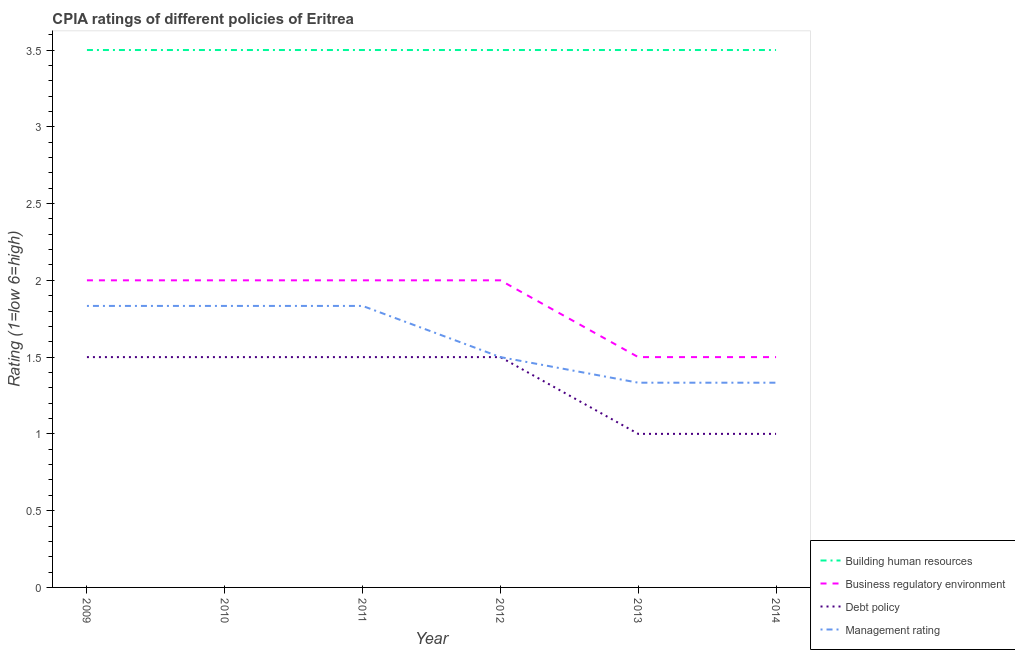How many different coloured lines are there?
Your response must be concise. 4. Across all years, what is the maximum cpia rating of management?
Make the answer very short. 1.83. Across all years, what is the minimum cpia rating of management?
Offer a very short reply. 1.33. In which year was the cpia rating of debt policy maximum?
Provide a short and direct response. 2009. In which year was the cpia rating of management minimum?
Ensure brevity in your answer.  2014. What is the difference between the cpia rating of building human resources in 2011 and that in 2014?
Your answer should be compact. 0. What is the difference between the cpia rating of debt policy in 2011 and the cpia rating of management in 2009?
Offer a very short reply. -0.33. What is the average cpia rating of management per year?
Offer a terse response. 1.61. In the year 2010, what is the difference between the cpia rating of management and cpia rating of business regulatory environment?
Provide a short and direct response. -0.17. What is the ratio of the cpia rating of business regulatory environment in 2009 to that in 2010?
Ensure brevity in your answer.  1. Is the difference between the cpia rating of business regulatory environment in 2010 and 2014 greater than the difference between the cpia rating of building human resources in 2010 and 2014?
Make the answer very short. Yes. What is the difference between the highest and the second highest cpia rating of debt policy?
Make the answer very short. 0. What is the difference between the highest and the lowest cpia rating of debt policy?
Your answer should be very brief. 0.5. Is the cpia rating of debt policy strictly greater than the cpia rating of management over the years?
Your answer should be compact. No. Is the cpia rating of debt policy strictly less than the cpia rating of building human resources over the years?
Your response must be concise. Yes. How many years are there in the graph?
Offer a very short reply. 6. What is the difference between two consecutive major ticks on the Y-axis?
Give a very brief answer. 0.5. Are the values on the major ticks of Y-axis written in scientific E-notation?
Give a very brief answer. No. Does the graph contain any zero values?
Keep it short and to the point. No. Does the graph contain grids?
Your response must be concise. No. Where does the legend appear in the graph?
Your response must be concise. Bottom right. How are the legend labels stacked?
Your answer should be compact. Vertical. What is the title of the graph?
Make the answer very short. CPIA ratings of different policies of Eritrea. Does "Burnt food" appear as one of the legend labels in the graph?
Offer a terse response. No. What is the Rating (1=low 6=high) in Building human resources in 2009?
Ensure brevity in your answer.  3.5. What is the Rating (1=low 6=high) of Management rating in 2009?
Make the answer very short. 1.83. What is the Rating (1=low 6=high) in Debt policy in 2010?
Your answer should be compact. 1.5. What is the Rating (1=low 6=high) in Management rating in 2010?
Keep it short and to the point. 1.83. What is the Rating (1=low 6=high) in Management rating in 2011?
Provide a short and direct response. 1.83. What is the Rating (1=low 6=high) in Building human resources in 2012?
Offer a very short reply. 3.5. What is the Rating (1=low 6=high) of Business regulatory environment in 2012?
Offer a terse response. 2. What is the Rating (1=low 6=high) of Management rating in 2012?
Provide a succinct answer. 1.5. What is the Rating (1=low 6=high) in Building human resources in 2013?
Your response must be concise. 3.5. What is the Rating (1=low 6=high) of Business regulatory environment in 2013?
Ensure brevity in your answer.  1.5. What is the Rating (1=low 6=high) of Management rating in 2013?
Make the answer very short. 1.33. What is the Rating (1=low 6=high) of Building human resources in 2014?
Provide a short and direct response. 3.5. What is the Rating (1=low 6=high) in Debt policy in 2014?
Provide a succinct answer. 1. What is the Rating (1=low 6=high) in Management rating in 2014?
Provide a succinct answer. 1.33. Across all years, what is the maximum Rating (1=low 6=high) of Management rating?
Keep it short and to the point. 1.83. Across all years, what is the minimum Rating (1=low 6=high) of Building human resources?
Your response must be concise. 3.5. Across all years, what is the minimum Rating (1=low 6=high) of Debt policy?
Your answer should be very brief. 1. Across all years, what is the minimum Rating (1=low 6=high) in Management rating?
Your response must be concise. 1.33. What is the total Rating (1=low 6=high) in Management rating in the graph?
Ensure brevity in your answer.  9.67. What is the difference between the Rating (1=low 6=high) in Business regulatory environment in 2009 and that in 2010?
Provide a short and direct response. 0. What is the difference between the Rating (1=low 6=high) in Debt policy in 2009 and that in 2010?
Give a very brief answer. 0. What is the difference between the Rating (1=low 6=high) of Management rating in 2009 and that in 2010?
Offer a terse response. 0. What is the difference between the Rating (1=low 6=high) of Building human resources in 2009 and that in 2011?
Your answer should be compact. 0. What is the difference between the Rating (1=low 6=high) in Debt policy in 2009 and that in 2011?
Offer a terse response. 0. What is the difference between the Rating (1=low 6=high) in Management rating in 2009 and that in 2011?
Provide a short and direct response. 0. What is the difference between the Rating (1=low 6=high) of Building human resources in 2009 and that in 2012?
Make the answer very short. 0. What is the difference between the Rating (1=low 6=high) of Debt policy in 2009 and that in 2012?
Make the answer very short. 0. What is the difference between the Rating (1=low 6=high) in Management rating in 2009 and that in 2012?
Provide a succinct answer. 0.33. What is the difference between the Rating (1=low 6=high) of Business regulatory environment in 2009 and that in 2013?
Keep it short and to the point. 0.5. What is the difference between the Rating (1=low 6=high) in Debt policy in 2009 and that in 2013?
Make the answer very short. 0.5. What is the difference between the Rating (1=low 6=high) in Business regulatory environment in 2009 and that in 2014?
Keep it short and to the point. 0.5. What is the difference between the Rating (1=low 6=high) of Debt policy in 2009 and that in 2014?
Offer a very short reply. 0.5. What is the difference between the Rating (1=low 6=high) in Management rating in 2009 and that in 2014?
Offer a very short reply. 0.5. What is the difference between the Rating (1=low 6=high) of Building human resources in 2010 and that in 2011?
Give a very brief answer. 0. What is the difference between the Rating (1=low 6=high) of Debt policy in 2010 and that in 2011?
Make the answer very short. 0. What is the difference between the Rating (1=low 6=high) of Business regulatory environment in 2010 and that in 2012?
Offer a terse response. 0. What is the difference between the Rating (1=low 6=high) in Debt policy in 2010 and that in 2012?
Your answer should be very brief. 0. What is the difference between the Rating (1=low 6=high) in Building human resources in 2010 and that in 2013?
Offer a very short reply. 0. What is the difference between the Rating (1=low 6=high) in Business regulatory environment in 2010 and that in 2014?
Your answer should be very brief. 0.5. What is the difference between the Rating (1=low 6=high) in Debt policy in 2010 and that in 2014?
Keep it short and to the point. 0.5. What is the difference between the Rating (1=low 6=high) of Management rating in 2010 and that in 2014?
Make the answer very short. 0.5. What is the difference between the Rating (1=low 6=high) of Management rating in 2011 and that in 2012?
Your answer should be very brief. 0.33. What is the difference between the Rating (1=low 6=high) in Building human resources in 2011 and that in 2013?
Provide a succinct answer. 0. What is the difference between the Rating (1=low 6=high) in Debt policy in 2011 and that in 2013?
Offer a terse response. 0.5. What is the difference between the Rating (1=low 6=high) of Management rating in 2011 and that in 2013?
Make the answer very short. 0.5. What is the difference between the Rating (1=low 6=high) in Building human resources in 2011 and that in 2014?
Offer a terse response. 0. What is the difference between the Rating (1=low 6=high) in Business regulatory environment in 2011 and that in 2014?
Your answer should be very brief. 0.5. What is the difference between the Rating (1=low 6=high) of Debt policy in 2011 and that in 2014?
Provide a short and direct response. 0.5. What is the difference between the Rating (1=low 6=high) of Business regulatory environment in 2012 and that in 2013?
Provide a short and direct response. 0.5. What is the difference between the Rating (1=low 6=high) of Debt policy in 2012 and that in 2013?
Make the answer very short. 0.5. What is the difference between the Rating (1=low 6=high) in Management rating in 2012 and that in 2013?
Keep it short and to the point. 0.17. What is the difference between the Rating (1=low 6=high) of Building human resources in 2012 and that in 2014?
Provide a short and direct response. 0. What is the difference between the Rating (1=low 6=high) in Business regulatory environment in 2013 and that in 2014?
Your answer should be compact. 0. What is the difference between the Rating (1=low 6=high) in Management rating in 2013 and that in 2014?
Provide a succinct answer. 0. What is the difference between the Rating (1=low 6=high) of Building human resources in 2009 and the Rating (1=low 6=high) of Business regulatory environment in 2010?
Make the answer very short. 1.5. What is the difference between the Rating (1=low 6=high) in Building human resources in 2009 and the Rating (1=low 6=high) in Management rating in 2010?
Provide a succinct answer. 1.67. What is the difference between the Rating (1=low 6=high) of Business regulatory environment in 2009 and the Rating (1=low 6=high) of Management rating in 2010?
Your response must be concise. 0.17. What is the difference between the Rating (1=low 6=high) in Debt policy in 2009 and the Rating (1=low 6=high) in Management rating in 2010?
Your response must be concise. -0.33. What is the difference between the Rating (1=low 6=high) in Building human resources in 2009 and the Rating (1=low 6=high) in Business regulatory environment in 2011?
Make the answer very short. 1.5. What is the difference between the Rating (1=low 6=high) in Building human resources in 2009 and the Rating (1=low 6=high) in Debt policy in 2011?
Keep it short and to the point. 2. What is the difference between the Rating (1=low 6=high) of Building human resources in 2009 and the Rating (1=low 6=high) of Management rating in 2011?
Offer a terse response. 1.67. What is the difference between the Rating (1=low 6=high) in Business regulatory environment in 2009 and the Rating (1=low 6=high) in Debt policy in 2011?
Give a very brief answer. 0.5. What is the difference between the Rating (1=low 6=high) in Business regulatory environment in 2009 and the Rating (1=low 6=high) in Management rating in 2011?
Provide a succinct answer. 0.17. What is the difference between the Rating (1=low 6=high) of Building human resources in 2009 and the Rating (1=low 6=high) of Debt policy in 2012?
Keep it short and to the point. 2. What is the difference between the Rating (1=low 6=high) of Building human resources in 2009 and the Rating (1=low 6=high) of Business regulatory environment in 2013?
Make the answer very short. 2. What is the difference between the Rating (1=low 6=high) of Building human resources in 2009 and the Rating (1=low 6=high) of Debt policy in 2013?
Provide a succinct answer. 2.5. What is the difference between the Rating (1=low 6=high) in Building human resources in 2009 and the Rating (1=low 6=high) in Management rating in 2013?
Give a very brief answer. 2.17. What is the difference between the Rating (1=low 6=high) in Business regulatory environment in 2009 and the Rating (1=low 6=high) in Management rating in 2013?
Your answer should be very brief. 0.67. What is the difference between the Rating (1=low 6=high) of Debt policy in 2009 and the Rating (1=low 6=high) of Management rating in 2013?
Keep it short and to the point. 0.17. What is the difference between the Rating (1=low 6=high) in Building human resources in 2009 and the Rating (1=low 6=high) in Management rating in 2014?
Offer a very short reply. 2.17. What is the difference between the Rating (1=low 6=high) of Business regulatory environment in 2009 and the Rating (1=low 6=high) of Management rating in 2014?
Offer a terse response. 0.67. What is the difference between the Rating (1=low 6=high) in Debt policy in 2009 and the Rating (1=low 6=high) in Management rating in 2014?
Your response must be concise. 0.17. What is the difference between the Rating (1=low 6=high) of Business regulatory environment in 2010 and the Rating (1=low 6=high) of Debt policy in 2011?
Offer a terse response. 0.5. What is the difference between the Rating (1=low 6=high) in Building human resources in 2010 and the Rating (1=low 6=high) in Debt policy in 2012?
Your response must be concise. 2. What is the difference between the Rating (1=low 6=high) in Business regulatory environment in 2010 and the Rating (1=low 6=high) in Debt policy in 2012?
Your response must be concise. 0.5. What is the difference between the Rating (1=low 6=high) in Debt policy in 2010 and the Rating (1=low 6=high) in Management rating in 2012?
Give a very brief answer. 0. What is the difference between the Rating (1=low 6=high) of Building human resources in 2010 and the Rating (1=low 6=high) of Management rating in 2013?
Your response must be concise. 2.17. What is the difference between the Rating (1=low 6=high) of Building human resources in 2010 and the Rating (1=low 6=high) of Debt policy in 2014?
Keep it short and to the point. 2.5. What is the difference between the Rating (1=low 6=high) in Building human resources in 2010 and the Rating (1=low 6=high) in Management rating in 2014?
Make the answer very short. 2.17. What is the difference between the Rating (1=low 6=high) of Business regulatory environment in 2010 and the Rating (1=low 6=high) of Debt policy in 2014?
Offer a very short reply. 1. What is the difference between the Rating (1=low 6=high) in Debt policy in 2010 and the Rating (1=low 6=high) in Management rating in 2014?
Make the answer very short. 0.17. What is the difference between the Rating (1=low 6=high) in Building human resources in 2011 and the Rating (1=low 6=high) in Business regulatory environment in 2012?
Offer a terse response. 1.5. What is the difference between the Rating (1=low 6=high) in Building human resources in 2011 and the Rating (1=low 6=high) in Debt policy in 2012?
Your answer should be compact. 2. What is the difference between the Rating (1=low 6=high) in Business regulatory environment in 2011 and the Rating (1=low 6=high) in Debt policy in 2012?
Your answer should be very brief. 0.5. What is the difference between the Rating (1=low 6=high) in Business regulatory environment in 2011 and the Rating (1=low 6=high) in Management rating in 2012?
Provide a short and direct response. 0.5. What is the difference between the Rating (1=low 6=high) in Building human resources in 2011 and the Rating (1=low 6=high) in Debt policy in 2013?
Provide a short and direct response. 2.5. What is the difference between the Rating (1=low 6=high) of Building human resources in 2011 and the Rating (1=low 6=high) of Management rating in 2013?
Your answer should be very brief. 2.17. What is the difference between the Rating (1=low 6=high) of Business regulatory environment in 2011 and the Rating (1=low 6=high) of Debt policy in 2013?
Offer a very short reply. 1. What is the difference between the Rating (1=low 6=high) of Building human resources in 2011 and the Rating (1=low 6=high) of Debt policy in 2014?
Ensure brevity in your answer.  2.5. What is the difference between the Rating (1=low 6=high) of Building human resources in 2011 and the Rating (1=low 6=high) of Management rating in 2014?
Your answer should be compact. 2.17. What is the difference between the Rating (1=low 6=high) in Business regulatory environment in 2011 and the Rating (1=low 6=high) in Debt policy in 2014?
Give a very brief answer. 1. What is the difference between the Rating (1=low 6=high) of Business regulatory environment in 2011 and the Rating (1=low 6=high) of Management rating in 2014?
Your answer should be very brief. 0.67. What is the difference between the Rating (1=low 6=high) of Building human resources in 2012 and the Rating (1=low 6=high) of Business regulatory environment in 2013?
Ensure brevity in your answer.  2. What is the difference between the Rating (1=low 6=high) in Building human resources in 2012 and the Rating (1=low 6=high) in Debt policy in 2013?
Provide a succinct answer. 2.5. What is the difference between the Rating (1=low 6=high) in Building human resources in 2012 and the Rating (1=low 6=high) in Management rating in 2013?
Your response must be concise. 2.17. What is the difference between the Rating (1=low 6=high) in Business regulatory environment in 2012 and the Rating (1=low 6=high) in Management rating in 2013?
Provide a succinct answer. 0.67. What is the difference between the Rating (1=low 6=high) of Building human resources in 2012 and the Rating (1=low 6=high) of Business regulatory environment in 2014?
Your answer should be compact. 2. What is the difference between the Rating (1=low 6=high) in Building human resources in 2012 and the Rating (1=low 6=high) in Management rating in 2014?
Offer a terse response. 2.17. What is the difference between the Rating (1=low 6=high) in Building human resources in 2013 and the Rating (1=low 6=high) in Management rating in 2014?
Your answer should be very brief. 2.17. What is the difference between the Rating (1=low 6=high) in Debt policy in 2013 and the Rating (1=low 6=high) in Management rating in 2014?
Make the answer very short. -0.33. What is the average Rating (1=low 6=high) of Building human resources per year?
Make the answer very short. 3.5. What is the average Rating (1=low 6=high) in Business regulatory environment per year?
Ensure brevity in your answer.  1.83. What is the average Rating (1=low 6=high) of Management rating per year?
Your answer should be compact. 1.61. In the year 2009, what is the difference between the Rating (1=low 6=high) of Building human resources and Rating (1=low 6=high) of Debt policy?
Provide a short and direct response. 2. In the year 2009, what is the difference between the Rating (1=low 6=high) in Building human resources and Rating (1=low 6=high) in Management rating?
Keep it short and to the point. 1.67. In the year 2009, what is the difference between the Rating (1=low 6=high) in Business regulatory environment and Rating (1=low 6=high) in Debt policy?
Your answer should be compact. 0.5. In the year 2009, what is the difference between the Rating (1=low 6=high) of Debt policy and Rating (1=low 6=high) of Management rating?
Your answer should be very brief. -0.33. In the year 2010, what is the difference between the Rating (1=low 6=high) of Building human resources and Rating (1=low 6=high) of Debt policy?
Give a very brief answer. 2. In the year 2010, what is the difference between the Rating (1=low 6=high) of Building human resources and Rating (1=low 6=high) of Management rating?
Give a very brief answer. 1.67. In the year 2010, what is the difference between the Rating (1=low 6=high) of Business regulatory environment and Rating (1=low 6=high) of Management rating?
Your response must be concise. 0.17. In the year 2011, what is the difference between the Rating (1=low 6=high) in Building human resources and Rating (1=low 6=high) in Business regulatory environment?
Make the answer very short. 1.5. In the year 2011, what is the difference between the Rating (1=low 6=high) in Building human resources and Rating (1=low 6=high) in Management rating?
Ensure brevity in your answer.  1.67. In the year 2011, what is the difference between the Rating (1=low 6=high) of Business regulatory environment and Rating (1=low 6=high) of Debt policy?
Your answer should be compact. 0.5. In the year 2011, what is the difference between the Rating (1=low 6=high) of Debt policy and Rating (1=low 6=high) of Management rating?
Ensure brevity in your answer.  -0.33. In the year 2012, what is the difference between the Rating (1=low 6=high) of Building human resources and Rating (1=low 6=high) of Business regulatory environment?
Provide a succinct answer. 1.5. In the year 2013, what is the difference between the Rating (1=low 6=high) in Building human resources and Rating (1=low 6=high) in Debt policy?
Provide a short and direct response. 2.5. In the year 2013, what is the difference between the Rating (1=low 6=high) of Building human resources and Rating (1=low 6=high) of Management rating?
Your answer should be very brief. 2.17. In the year 2014, what is the difference between the Rating (1=low 6=high) in Building human resources and Rating (1=low 6=high) in Management rating?
Ensure brevity in your answer.  2.17. In the year 2014, what is the difference between the Rating (1=low 6=high) of Business regulatory environment and Rating (1=low 6=high) of Debt policy?
Offer a very short reply. 0.5. In the year 2014, what is the difference between the Rating (1=low 6=high) of Debt policy and Rating (1=low 6=high) of Management rating?
Your answer should be very brief. -0.33. What is the ratio of the Rating (1=low 6=high) in Building human resources in 2009 to that in 2010?
Provide a succinct answer. 1. What is the ratio of the Rating (1=low 6=high) in Business regulatory environment in 2009 to that in 2010?
Ensure brevity in your answer.  1. What is the ratio of the Rating (1=low 6=high) in Building human resources in 2009 to that in 2011?
Ensure brevity in your answer.  1. What is the ratio of the Rating (1=low 6=high) in Business regulatory environment in 2009 to that in 2011?
Ensure brevity in your answer.  1. What is the ratio of the Rating (1=low 6=high) of Debt policy in 2009 to that in 2011?
Offer a terse response. 1. What is the ratio of the Rating (1=low 6=high) of Management rating in 2009 to that in 2011?
Provide a succinct answer. 1. What is the ratio of the Rating (1=low 6=high) of Business regulatory environment in 2009 to that in 2012?
Your answer should be very brief. 1. What is the ratio of the Rating (1=low 6=high) of Debt policy in 2009 to that in 2012?
Your answer should be very brief. 1. What is the ratio of the Rating (1=low 6=high) in Management rating in 2009 to that in 2012?
Make the answer very short. 1.22. What is the ratio of the Rating (1=low 6=high) of Building human resources in 2009 to that in 2013?
Offer a very short reply. 1. What is the ratio of the Rating (1=low 6=high) of Debt policy in 2009 to that in 2013?
Keep it short and to the point. 1.5. What is the ratio of the Rating (1=low 6=high) of Management rating in 2009 to that in 2013?
Offer a very short reply. 1.38. What is the ratio of the Rating (1=low 6=high) in Business regulatory environment in 2009 to that in 2014?
Your response must be concise. 1.33. What is the ratio of the Rating (1=low 6=high) in Debt policy in 2009 to that in 2014?
Ensure brevity in your answer.  1.5. What is the ratio of the Rating (1=low 6=high) in Management rating in 2009 to that in 2014?
Provide a succinct answer. 1.38. What is the ratio of the Rating (1=low 6=high) of Debt policy in 2010 to that in 2011?
Keep it short and to the point. 1. What is the ratio of the Rating (1=low 6=high) of Management rating in 2010 to that in 2011?
Your answer should be very brief. 1. What is the ratio of the Rating (1=low 6=high) in Building human resources in 2010 to that in 2012?
Provide a short and direct response. 1. What is the ratio of the Rating (1=low 6=high) in Management rating in 2010 to that in 2012?
Your answer should be very brief. 1.22. What is the ratio of the Rating (1=low 6=high) in Building human resources in 2010 to that in 2013?
Provide a short and direct response. 1. What is the ratio of the Rating (1=low 6=high) of Business regulatory environment in 2010 to that in 2013?
Provide a succinct answer. 1.33. What is the ratio of the Rating (1=low 6=high) of Management rating in 2010 to that in 2013?
Provide a short and direct response. 1.38. What is the ratio of the Rating (1=low 6=high) in Management rating in 2010 to that in 2014?
Ensure brevity in your answer.  1.38. What is the ratio of the Rating (1=low 6=high) in Building human resources in 2011 to that in 2012?
Your response must be concise. 1. What is the ratio of the Rating (1=low 6=high) of Business regulatory environment in 2011 to that in 2012?
Offer a very short reply. 1. What is the ratio of the Rating (1=low 6=high) of Management rating in 2011 to that in 2012?
Ensure brevity in your answer.  1.22. What is the ratio of the Rating (1=low 6=high) of Debt policy in 2011 to that in 2013?
Your answer should be compact. 1.5. What is the ratio of the Rating (1=low 6=high) of Management rating in 2011 to that in 2013?
Offer a terse response. 1.38. What is the ratio of the Rating (1=low 6=high) in Business regulatory environment in 2011 to that in 2014?
Your answer should be compact. 1.33. What is the ratio of the Rating (1=low 6=high) in Management rating in 2011 to that in 2014?
Your answer should be very brief. 1.38. What is the ratio of the Rating (1=low 6=high) in Building human resources in 2012 to that in 2013?
Keep it short and to the point. 1. What is the ratio of the Rating (1=low 6=high) of Business regulatory environment in 2012 to that in 2013?
Offer a very short reply. 1.33. What is the ratio of the Rating (1=low 6=high) in Debt policy in 2012 to that in 2013?
Make the answer very short. 1.5. What is the ratio of the Rating (1=low 6=high) of Management rating in 2012 to that in 2013?
Provide a succinct answer. 1.12. What is the ratio of the Rating (1=low 6=high) in Debt policy in 2012 to that in 2014?
Offer a very short reply. 1.5. What is the ratio of the Rating (1=low 6=high) of Management rating in 2013 to that in 2014?
Keep it short and to the point. 1. What is the difference between the highest and the second highest Rating (1=low 6=high) in Building human resources?
Keep it short and to the point. 0. What is the difference between the highest and the second highest Rating (1=low 6=high) in Debt policy?
Keep it short and to the point. 0. What is the difference between the highest and the lowest Rating (1=low 6=high) of Building human resources?
Provide a succinct answer. 0. What is the difference between the highest and the lowest Rating (1=low 6=high) of Debt policy?
Your answer should be very brief. 0.5. 